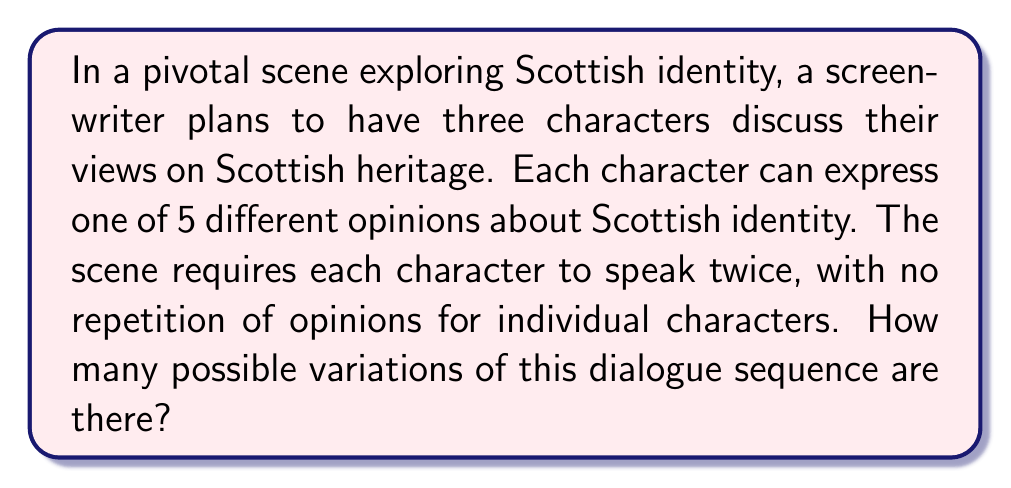Could you help me with this problem? Let's break this down step-by-step:

1) We have 3 characters, each speaking twice.

2) For each character's first line, they have 5 choices of opinion to express.

3) For each character's second line, they have 4 choices, as they cannot repeat their first opinion.

4) For each character, we can use the multiplication principle. The number of ways each character can express their two opinions is:

   $5 \times 4 = 20$

5) Now, we need to consider all three characters together. Since each character's choices are independent of the others, we again use the multiplication principle:

   $20 \times 20 \times 20 = 8000$

6) However, this isn't our final answer. The question asks for the number of dialogue sequences. The order in which the characters speak matters.

7) With 3 characters each speaking twice, we have 6 speaking slots to arrange. This is a permutation of 6 items, where there are 2 indistinguishable items for each character (their two lines).

8) The number of ways to arrange these 6 speaking slots is:

   $$\frac{6!}{(2!)^3} = \frac{720}{8} = 90$$

9) Finally, we multiply the number of ways to choose opinions (8000) by the number of ways to arrange the speaking order (90):

   $8000 \times 90 = 720000$

Therefore, there are 720,000 possible variations of this dialogue sequence.
Answer: $720000$ 